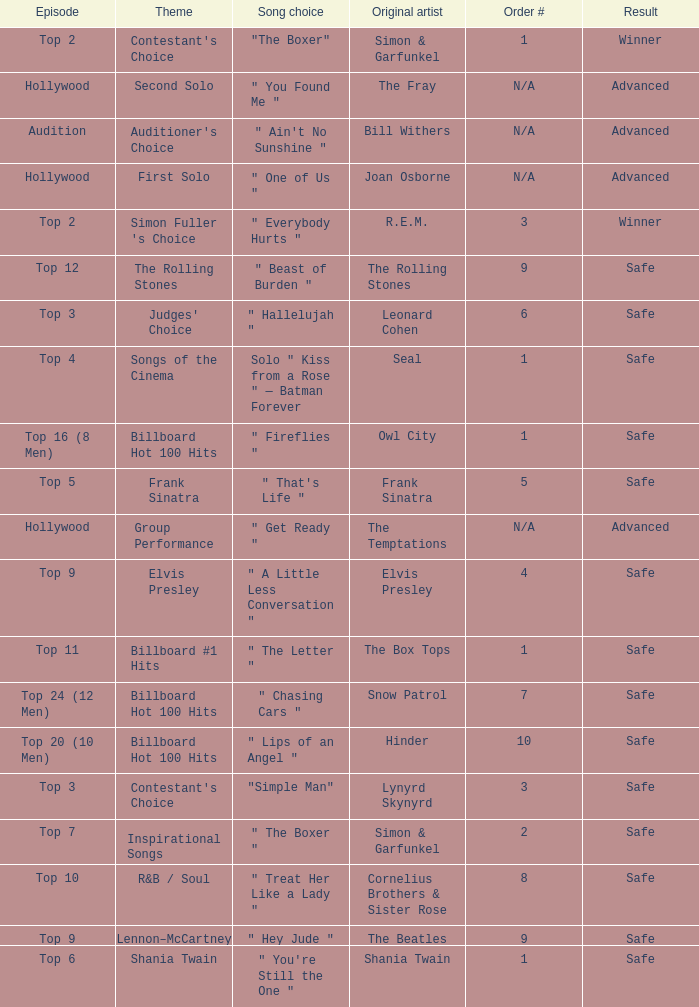What are the themes present in the top 16 (8 men) episode? Billboard Hot 100 Hits. Could you parse the entire table as a dict? {'header': ['Episode', 'Theme', 'Song choice', 'Original artist', 'Order #', 'Result'], 'rows': [['Top 2', "Contestant's Choice", '"The Boxer"', 'Simon & Garfunkel', '1', 'Winner'], ['Hollywood', 'Second Solo', '" You Found Me "', 'The Fray', 'N/A', 'Advanced'], ['Audition', "Auditioner's Choice", '" Ain\'t No Sunshine "', 'Bill Withers', 'N/A', 'Advanced'], ['Hollywood', 'First Solo', '" One of Us "', 'Joan Osborne', 'N/A', 'Advanced'], ['Top 2', "Simon Fuller 's Choice", '" Everybody Hurts "', 'R.E.M.', '3', 'Winner'], ['Top 12', 'The Rolling Stones', '" Beast of Burden "', 'The Rolling Stones', '9', 'Safe'], ['Top 3', "Judges' Choice", '" Hallelujah "', 'Leonard Cohen', '6', 'Safe'], ['Top 4', 'Songs of the Cinema', 'Solo " Kiss from a Rose " — Batman Forever', 'Seal', '1', 'Safe'], ['Top 16 (8 Men)', 'Billboard Hot 100 Hits', '" Fireflies "', 'Owl City', '1', 'Safe'], ['Top 5', 'Frank Sinatra', '" That\'s Life "', 'Frank Sinatra', '5', 'Safe'], ['Hollywood', 'Group Performance', '" Get Ready "', 'The Temptations', 'N/A', 'Advanced'], ['Top 9', 'Elvis Presley', '" A Little Less Conversation "', 'Elvis Presley', '4', 'Safe'], ['Top 11', 'Billboard #1 Hits', '" The Letter "', 'The Box Tops', '1', 'Safe'], ['Top 24 (12 Men)', 'Billboard Hot 100 Hits', '" Chasing Cars "', 'Snow Patrol', '7', 'Safe'], ['Top 20 (10 Men)', 'Billboard Hot 100 Hits', '" Lips of an Angel "', 'Hinder', '10', 'Safe'], ['Top 3', "Contestant's Choice", '"Simple Man"', 'Lynyrd Skynyrd', '3', 'Safe'], ['Top 7', 'Inspirational Songs', '" The Boxer "', 'Simon & Garfunkel', '2', 'Safe'], ['Top 10', 'R&B / Soul', '" Treat Her Like a Lady "', 'Cornelius Brothers & Sister Rose', '8', 'Safe'], ['Top 9', 'Lennon–McCartney', '" Hey Jude "', 'The Beatles', '9', 'Safe'], ['Top 6', 'Shania Twain', '" You\'re Still the One "', 'Shania Twain', '1', 'Safe']]} 